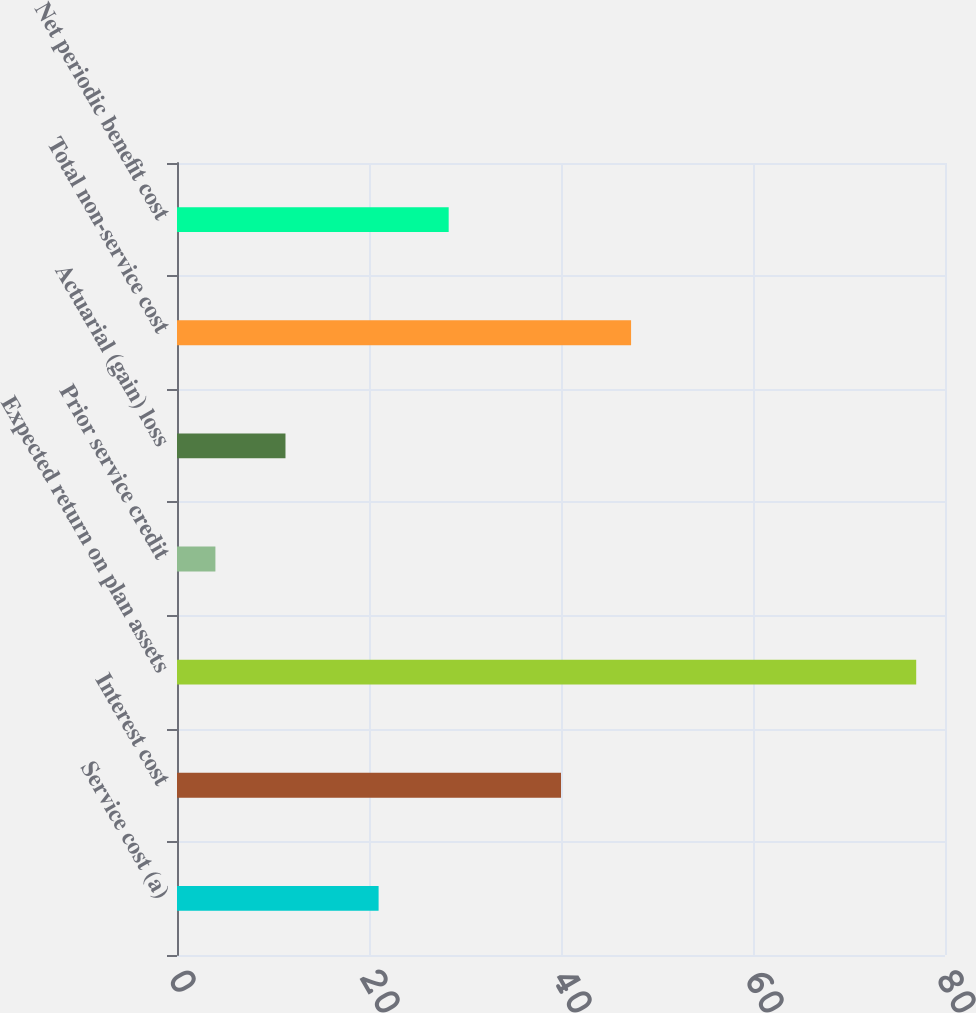Convert chart to OTSL. <chart><loc_0><loc_0><loc_500><loc_500><bar_chart><fcel>Service cost (a)<fcel>Interest cost<fcel>Expected return on plan assets<fcel>Prior service credit<fcel>Actuarial (gain) loss<fcel>Total non-service cost<fcel>Net periodic benefit cost<nl><fcel>21<fcel>40<fcel>77<fcel>4<fcel>11.3<fcel>47.3<fcel>28.3<nl></chart> 